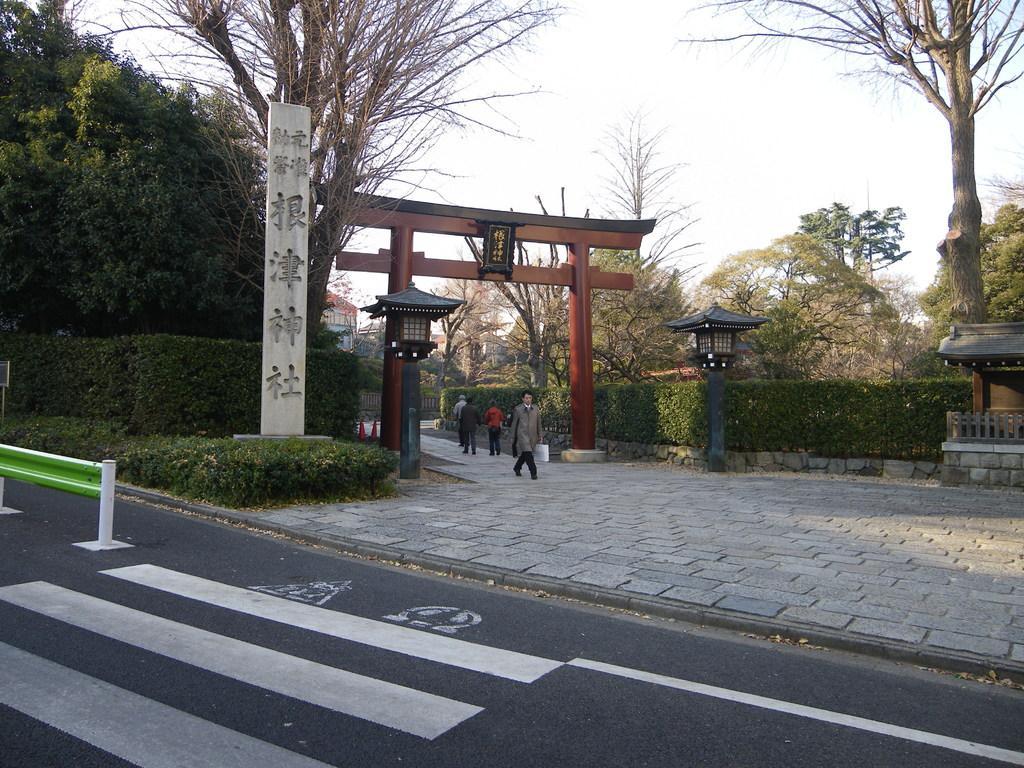Can you describe this image briefly? There are four persons. Here we can see plants, road, pillars, trees, and buildings. In the background there is sky. 